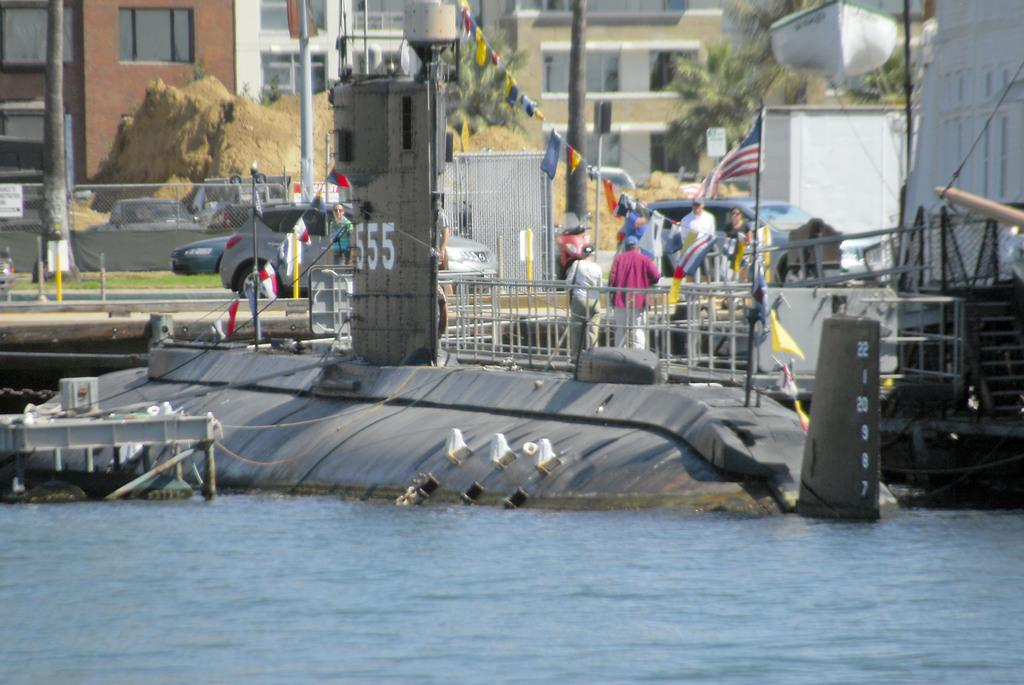What type of structures can be seen in the image? There are buildings in the image. What natural features are present in the image? There are hills and trees in the image. What objects are used for cooking in the image? There are grills in the image. What are the people in the image doing? There are persons standing on the ground in the image. What mode of transportation can be seen in the image? Motor vehicles are visible in the image. What decorative items are present in the image? Flags tied to ropes are present in the image. What type of wood is used to build the fairies' homes in the image? There are no fairies or homes for them in the image. How does the time in the image affect the activities of the people? The provided facts do not mention the time of day or how it affects the activities of the people in the image. 